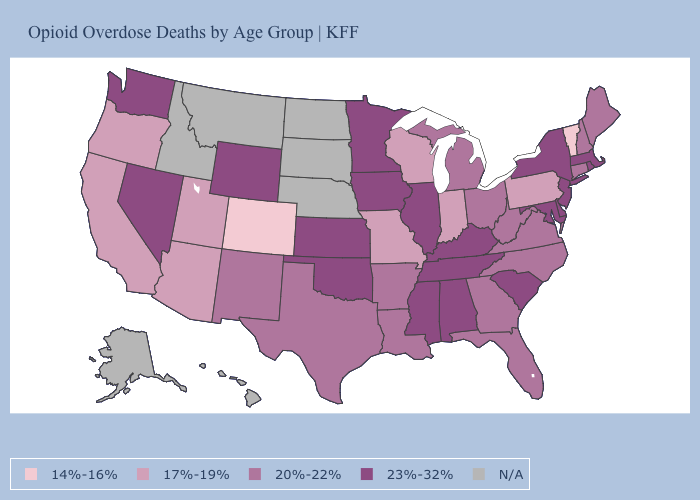Does New Hampshire have the lowest value in the USA?
Be succinct. No. Among the states that border California , does Nevada have the highest value?
Short answer required. Yes. Which states have the highest value in the USA?
Give a very brief answer. Alabama, Delaware, Illinois, Iowa, Kansas, Kentucky, Maryland, Massachusetts, Minnesota, Mississippi, Nevada, New Jersey, New York, Oklahoma, Rhode Island, South Carolina, Tennessee, Washington, Wyoming. What is the value of Illinois?
Answer briefly. 23%-32%. What is the highest value in the South ?
Quick response, please. 23%-32%. What is the lowest value in the USA?
Answer briefly. 14%-16%. What is the highest value in the Northeast ?
Be succinct. 23%-32%. Does Utah have the lowest value in the USA?
Answer briefly. No. Name the states that have a value in the range N/A?
Concise answer only. Alaska, Hawaii, Idaho, Montana, Nebraska, North Dakota, South Dakota. What is the value of Tennessee?
Quick response, please. 23%-32%. What is the lowest value in the MidWest?
Keep it brief. 17%-19%. Name the states that have a value in the range 23%-32%?
Be succinct. Alabama, Delaware, Illinois, Iowa, Kansas, Kentucky, Maryland, Massachusetts, Minnesota, Mississippi, Nevada, New Jersey, New York, Oklahoma, Rhode Island, South Carolina, Tennessee, Washington, Wyoming. What is the lowest value in the Northeast?
Be succinct. 14%-16%. Name the states that have a value in the range 17%-19%?
Short answer required. Arizona, California, Indiana, Missouri, Oregon, Pennsylvania, Utah, Wisconsin. 